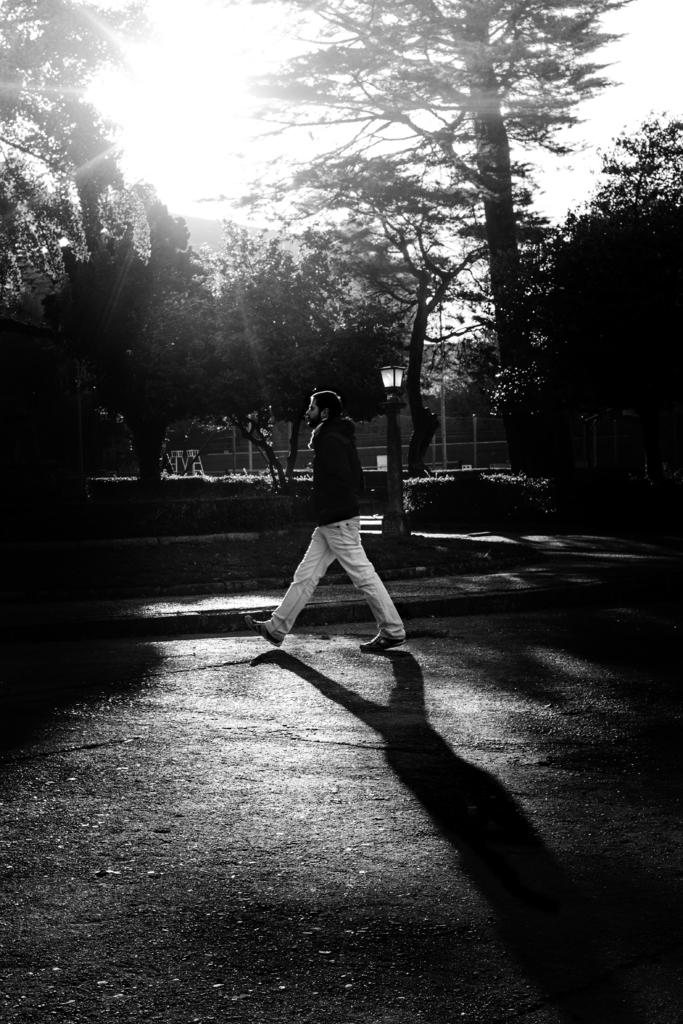What is the color scheme of the image? The image is black and white. What is the man in the image doing? The man is walking on the road. What can be seen in the background of the image? There are trees, plants, light, and the sky visible in the background. What type of watch is the clam wearing in the image? There is no clam or watch present in the image. 